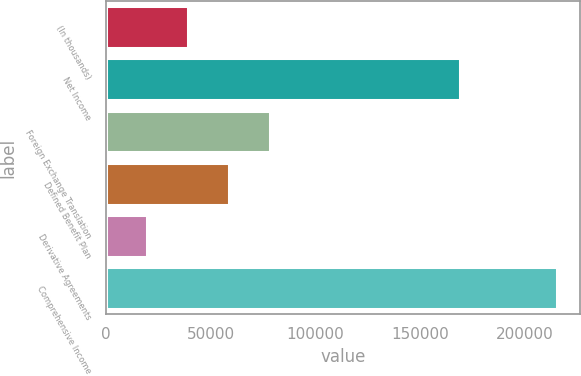Convert chart to OTSL. <chart><loc_0><loc_0><loc_500><loc_500><bar_chart><fcel>(In thousands)<fcel>Net Income<fcel>Foreign Exchange Translation<fcel>Defined Benefit Plan<fcel>Derivative Agreements<fcel>Comprehensive Income<nl><fcel>39298.4<fcel>169031<fcel>78473.8<fcel>58886.1<fcel>19710.7<fcel>215465<nl></chart> 